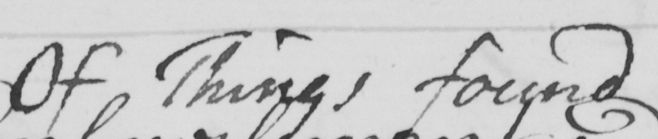What text is written in this handwritten line? Of Things found 